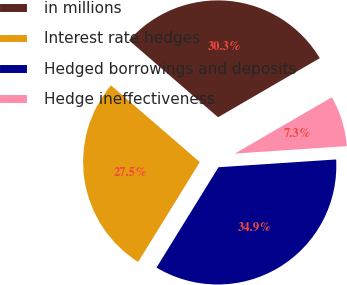Convert chart. <chart><loc_0><loc_0><loc_500><loc_500><pie_chart><fcel>in millions<fcel>Interest rate hedges<fcel>Hedged borrowings and deposits<fcel>Hedge ineffectiveness<nl><fcel>30.29%<fcel>27.53%<fcel>34.86%<fcel>7.32%<nl></chart> 